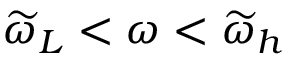<formula> <loc_0><loc_0><loc_500><loc_500>\widetilde { \omega } _ { L } < \omega < \widetilde { \omega } _ { h }</formula> 